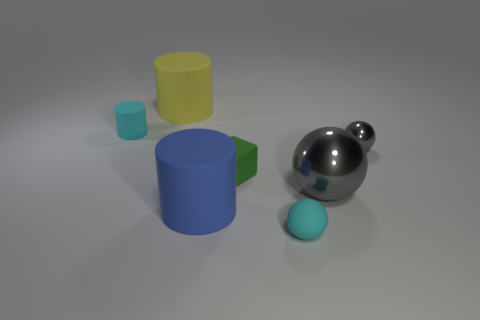How many rubber cylinders are behind the tiny ball behind the tiny cyan rubber sphere in front of the green object?
Your answer should be very brief. 2. There is a cyan object on the right side of the blue cylinder; is its shape the same as the large blue rubber thing?
Offer a terse response. No. What is the material of the small object that is to the right of the small cyan rubber ball?
Make the answer very short. Metal. What shape is the matte object that is on the left side of the large blue matte thing and on the right side of the cyan cylinder?
Offer a terse response. Cylinder. What is the green thing made of?
Your response must be concise. Rubber. What number of blocks are small rubber objects or gray things?
Make the answer very short. 1. Is the material of the large yellow cylinder the same as the small green cube?
Your response must be concise. Yes. The cyan rubber object that is the same shape as the blue rubber object is what size?
Keep it short and to the point. Small. What material is the big object that is both left of the large ball and behind the blue matte thing?
Your response must be concise. Rubber. Are there an equal number of small cyan matte cylinders that are to the right of the yellow rubber cylinder and blue metal spheres?
Ensure brevity in your answer.  Yes. 